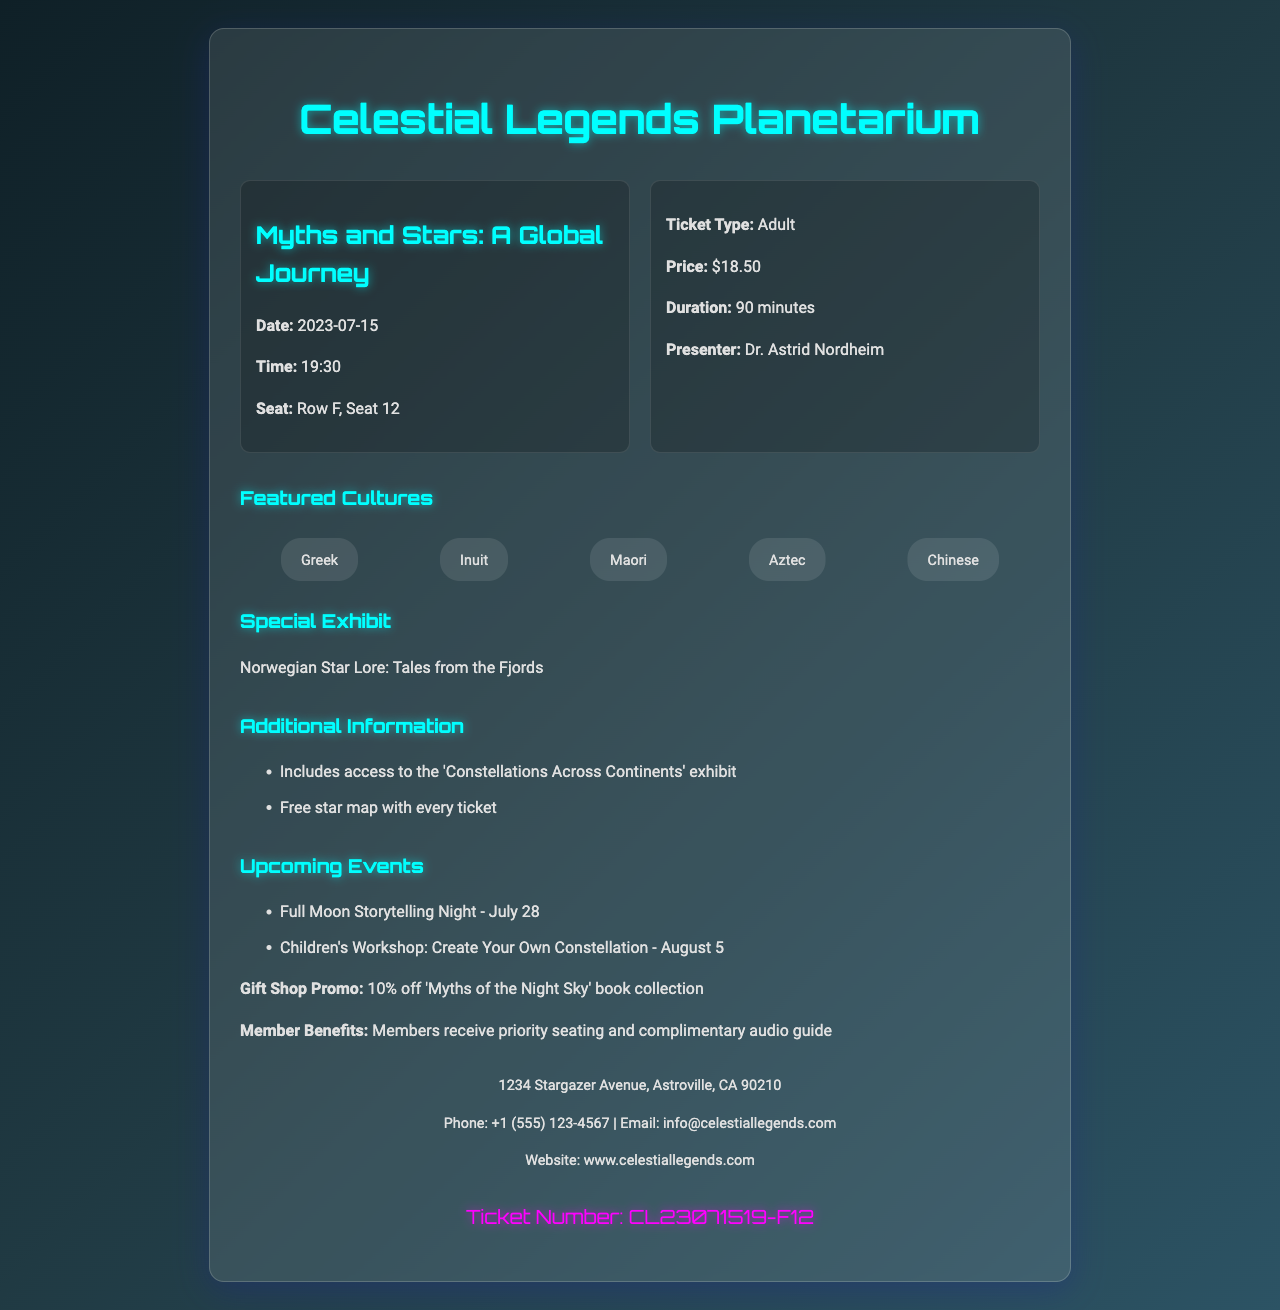what is the name of the planetarium? The name of the planetarium is located at the top of the document.
Answer: Celestial Legends Planetarium what is the show title? The show title is listed in the ticket information section.
Answer: Myths and Stars: A Global Journey when is the show date? The show date is mentioned in the ticket information section.
Answer: 2023-07-15 who is the presenter of the show? The presenter's name is provided in the ticket information.
Answer: Dr. Astrid Nordheim how much does an adult ticket cost? The ticket price is clearly stated in the ticket information section.
Answer: $18.50 what is included with the ticket? Additional information lists what comes with the ticket purchase.
Answer: Free star map with every ticket how many different cultures are featured in the show? The featured cultures section lists the cultures represented in the show.
Answer: Five what is the ticket number? The ticket number is specified at the bottom of the document.
Answer: CL23071519-F12 what benefits do members receive? Member benefits are outlined in the additional information section.
Answer: Priority seating and complimentary audio guide 